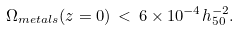<formula> <loc_0><loc_0><loc_500><loc_500>\Omega _ { m e t a l s } ( z = 0 ) \, < \, 6 \times 1 0 ^ { - 4 } h _ { 5 0 } ^ { - 2 } .</formula> 